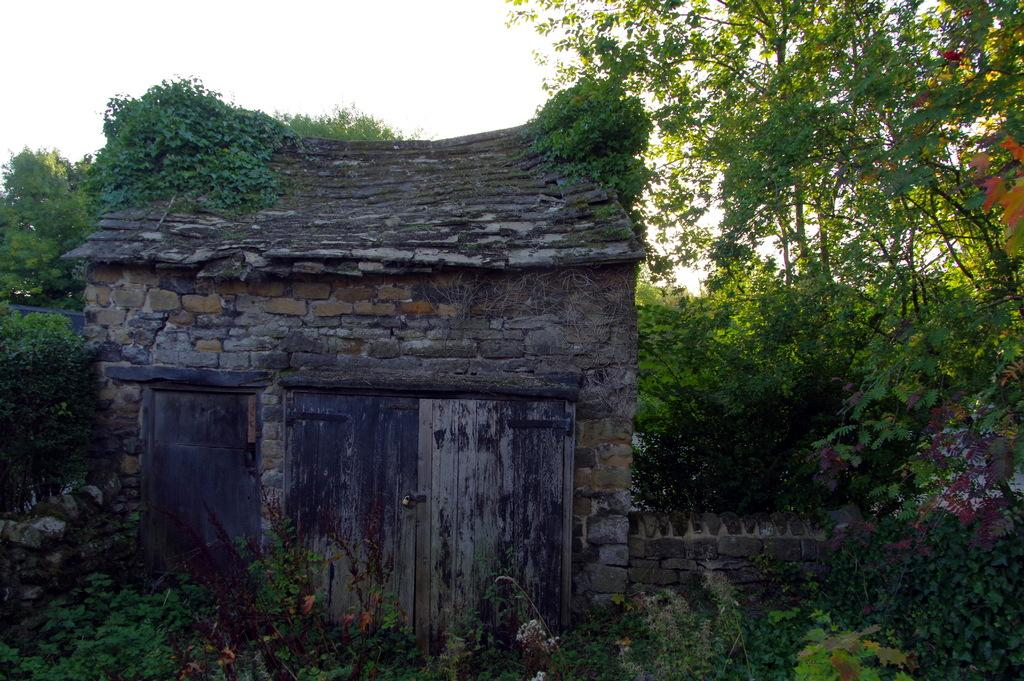What is the main subject in the middle of the image? There is a house in the middle of the image. What can be seen in the background of the image? There are trees in the background of the image. What is visible at the top of the image? The sky is visible at the top of the image. What type of notebook is being used by the tree in the image? There is no notebook present in the image, as it features a house, trees, and the sky. 